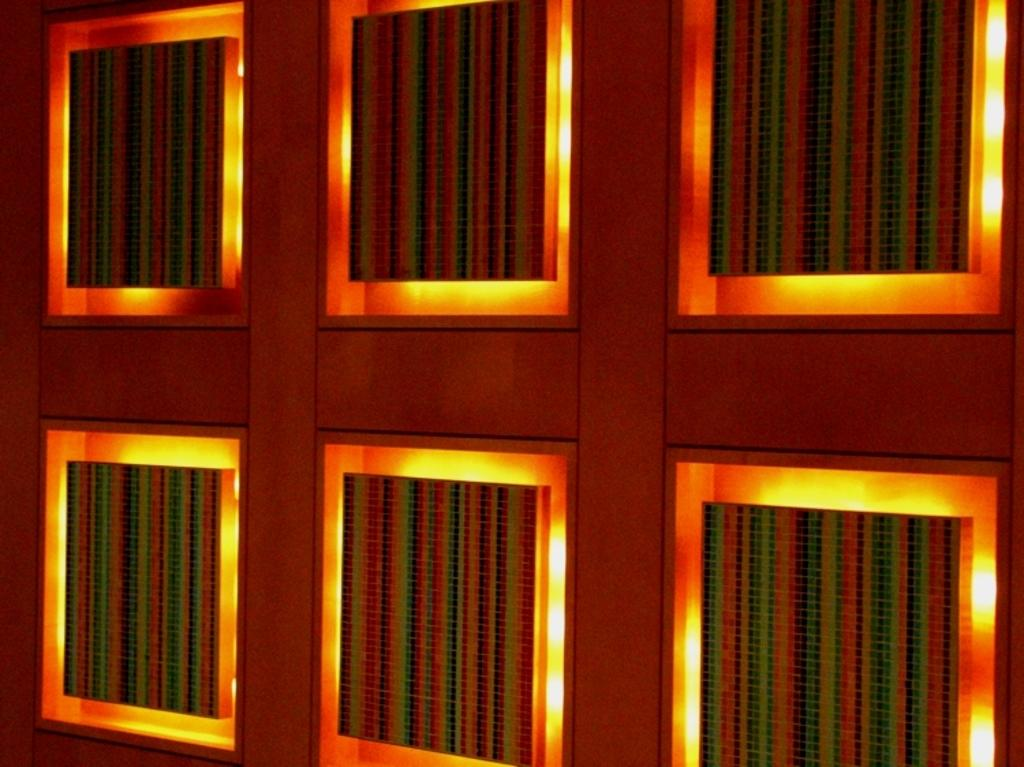What is present on the wall in the image? The wall has decorative frames and lightning. Can you describe the decorative frames on the wall? Unfortunately, the details of the decorative frames cannot be determined from the provided facts. What type of lightning is present on the wall? The facts do not specify the type of lightning on the wall. How many wheels can be seen on the wall in the image? There are no wheels present on the wall in the image. Are there any brothers playing with a ball near the wall? There is no mention of any brothers or a ball in the provided facts, and therefore no such activity can be observed. 